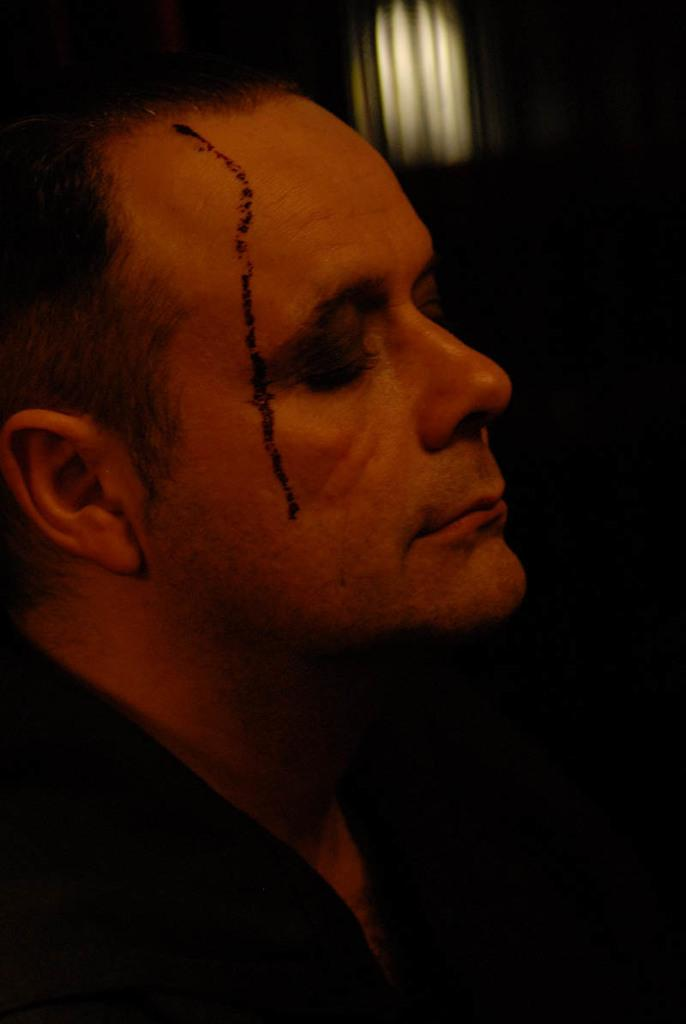What is the main subject of the image? There is a man in the image. What is the man wearing in the image? The man is wearing a black color shirt. How many girls are present in the image? There is no mention of girls in the image; it only features a man wearing a black color shirt. What type of goat can be seen in the image? There is no goat present in the image; it only features a man wearing a black color shirt. 